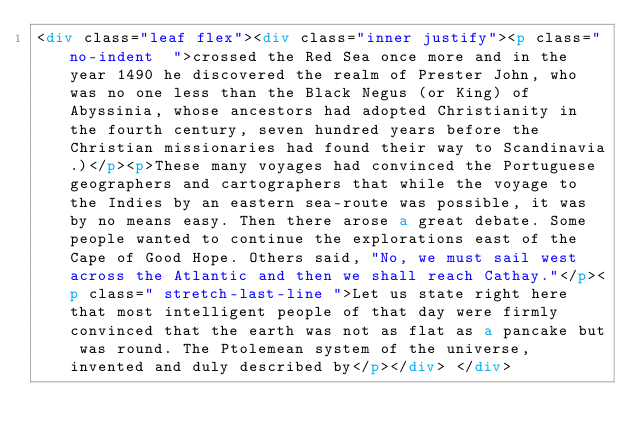Convert code to text. <code><loc_0><loc_0><loc_500><loc_500><_HTML_><div class="leaf flex"><div class="inner justify"><p class="no-indent  ">crossed the Red Sea once more and in the year 1490 he discovered the realm of Prester John, who was no one less than the Black Negus (or King) of Abyssinia, whose ancestors had adopted Christianity in the fourth century, seven hundred years before the Christian missionaries had found their way to Scandinavia.)</p><p>These many voyages had convinced the Portuguese geographers and cartographers that while the voyage to the Indies by an eastern sea-route was possible, it was by no means easy. Then there arose a great debate. Some people wanted to continue the explorations east of the Cape of Good Hope. Others said, "No, we must sail west across the Atlantic and then we shall reach Cathay."</p><p class=" stretch-last-line ">Let us state right here that most intelligent people of that day were firmly convinced that the earth was not as flat as a pancake but was round. The Ptolemean system of the universe, invented and duly described by</p></div> </div></code> 